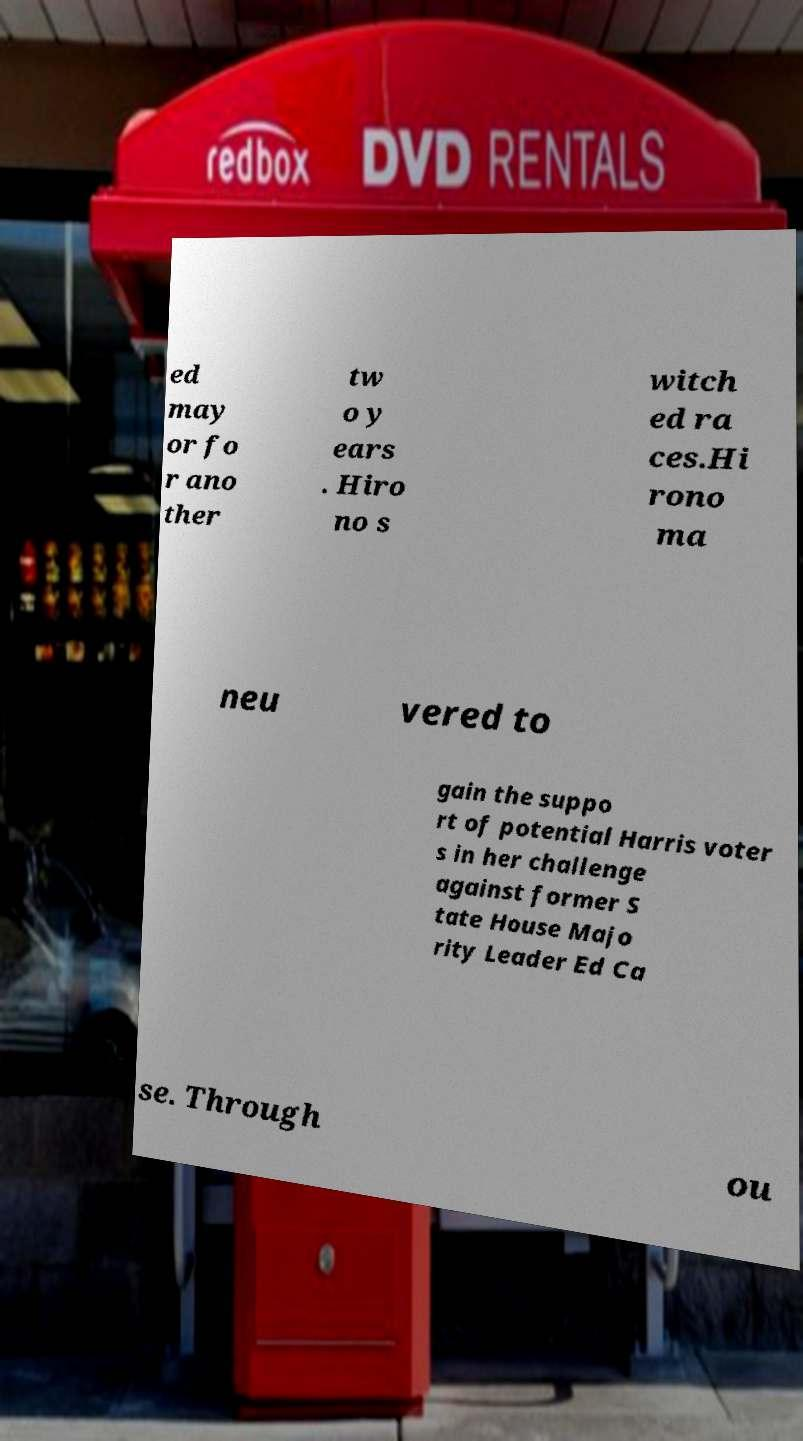Could you extract and type out the text from this image? ed may or fo r ano ther tw o y ears . Hiro no s witch ed ra ces.Hi rono ma neu vered to gain the suppo rt of potential Harris voter s in her challenge against former S tate House Majo rity Leader Ed Ca se. Through ou 